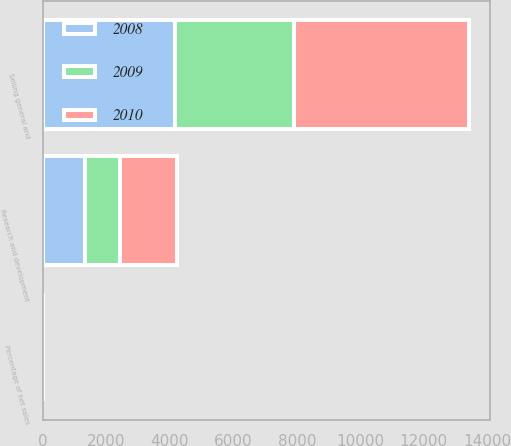Convert chart to OTSL. <chart><loc_0><loc_0><loc_500><loc_500><stacked_bar_chart><ecel><fcel>Research and development<fcel>Percentage of net sales<fcel>Selling general and<nl><fcel>2010<fcel>1782<fcel>2.7<fcel>5517<nl><fcel>2008<fcel>1333<fcel>3.1<fcel>4149<nl><fcel>2009<fcel>1109<fcel>3<fcel>3761<nl></chart> 